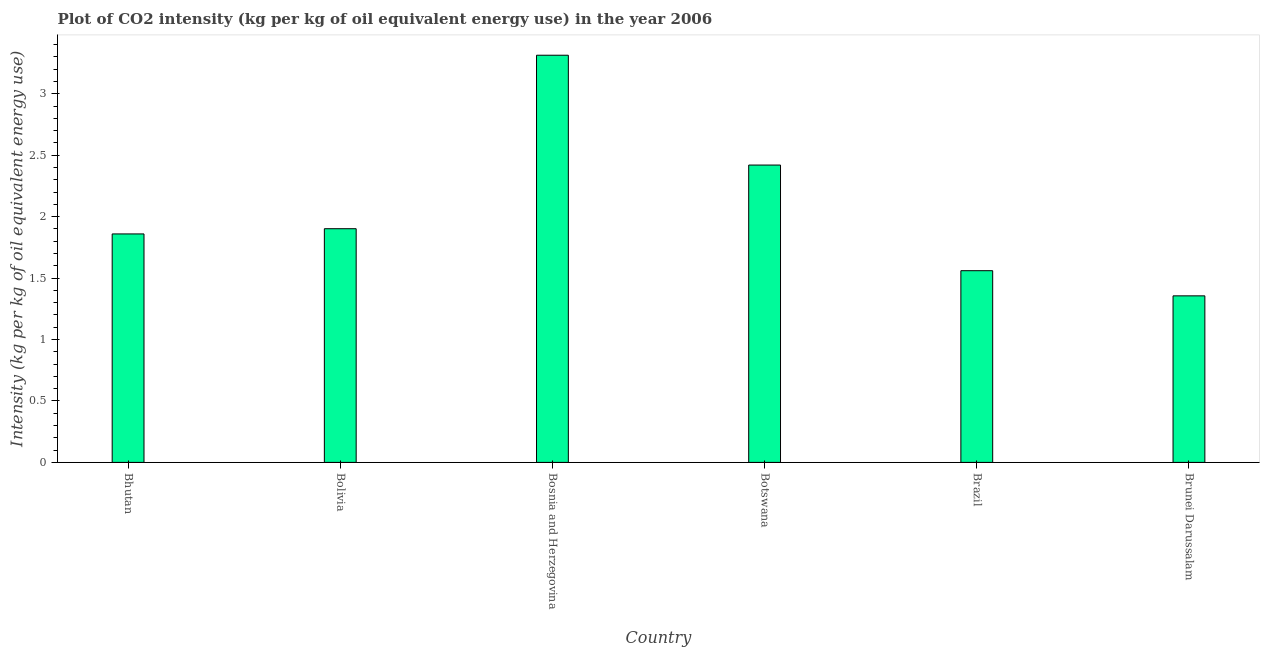Does the graph contain any zero values?
Your answer should be compact. No. What is the title of the graph?
Offer a very short reply. Plot of CO2 intensity (kg per kg of oil equivalent energy use) in the year 2006. What is the label or title of the X-axis?
Make the answer very short. Country. What is the label or title of the Y-axis?
Offer a very short reply. Intensity (kg per kg of oil equivalent energy use). What is the co2 intensity in Brazil?
Your answer should be compact. 1.56. Across all countries, what is the maximum co2 intensity?
Your answer should be very brief. 3.31. Across all countries, what is the minimum co2 intensity?
Your answer should be very brief. 1.36. In which country was the co2 intensity maximum?
Ensure brevity in your answer.  Bosnia and Herzegovina. In which country was the co2 intensity minimum?
Keep it short and to the point. Brunei Darussalam. What is the sum of the co2 intensity?
Provide a short and direct response. 12.41. What is the difference between the co2 intensity in Bolivia and Botswana?
Keep it short and to the point. -0.52. What is the average co2 intensity per country?
Provide a succinct answer. 2.07. What is the median co2 intensity?
Provide a short and direct response. 1.88. In how many countries, is the co2 intensity greater than 1.2 kg?
Offer a very short reply. 6. What is the ratio of the co2 intensity in Botswana to that in Brunei Darussalam?
Your answer should be very brief. 1.78. Is the co2 intensity in Bhutan less than that in Brazil?
Your response must be concise. No. Is the difference between the co2 intensity in Bolivia and Brunei Darussalam greater than the difference between any two countries?
Your response must be concise. No. What is the difference between the highest and the second highest co2 intensity?
Provide a short and direct response. 0.89. What is the difference between the highest and the lowest co2 intensity?
Offer a terse response. 1.96. Are the values on the major ticks of Y-axis written in scientific E-notation?
Keep it short and to the point. No. What is the Intensity (kg per kg of oil equivalent energy use) in Bhutan?
Your answer should be very brief. 1.86. What is the Intensity (kg per kg of oil equivalent energy use) in Bolivia?
Provide a short and direct response. 1.9. What is the Intensity (kg per kg of oil equivalent energy use) of Bosnia and Herzegovina?
Your answer should be very brief. 3.31. What is the Intensity (kg per kg of oil equivalent energy use) of Botswana?
Ensure brevity in your answer.  2.42. What is the Intensity (kg per kg of oil equivalent energy use) of Brazil?
Keep it short and to the point. 1.56. What is the Intensity (kg per kg of oil equivalent energy use) in Brunei Darussalam?
Give a very brief answer. 1.36. What is the difference between the Intensity (kg per kg of oil equivalent energy use) in Bhutan and Bolivia?
Your answer should be very brief. -0.04. What is the difference between the Intensity (kg per kg of oil equivalent energy use) in Bhutan and Bosnia and Herzegovina?
Provide a short and direct response. -1.45. What is the difference between the Intensity (kg per kg of oil equivalent energy use) in Bhutan and Botswana?
Give a very brief answer. -0.56. What is the difference between the Intensity (kg per kg of oil equivalent energy use) in Bhutan and Brazil?
Provide a succinct answer. 0.3. What is the difference between the Intensity (kg per kg of oil equivalent energy use) in Bhutan and Brunei Darussalam?
Provide a succinct answer. 0.5. What is the difference between the Intensity (kg per kg of oil equivalent energy use) in Bolivia and Bosnia and Herzegovina?
Your answer should be very brief. -1.41. What is the difference between the Intensity (kg per kg of oil equivalent energy use) in Bolivia and Botswana?
Offer a terse response. -0.52. What is the difference between the Intensity (kg per kg of oil equivalent energy use) in Bolivia and Brazil?
Your response must be concise. 0.34. What is the difference between the Intensity (kg per kg of oil equivalent energy use) in Bolivia and Brunei Darussalam?
Keep it short and to the point. 0.55. What is the difference between the Intensity (kg per kg of oil equivalent energy use) in Bosnia and Herzegovina and Botswana?
Make the answer very short. 0.89. What is the difference between the Intensity (kg per kg of oil equivalent energy use) in Bosnia and Herzegovina and Brazil?
Give a very brief answer. 1.75. What is the difference between the Intensity (kg per kg of oil equivalent energy use) in Bosnia and Herzegovina and Brunei Darussalam?
Provide a succinct answer. 1.96. What is the difference between the Intensity (kg per kg of oil equivalent energy use) in Botswana and Brazil?
Provide a short and direct response. 0.86. What is the difference between the Intensity (kg per kg of oil equivalent energy use) in Botswana and Brunei Darussalam?
Offer a very short reply. 1.06. What is the difference between the Intensity (kg per kg of oil equivalent energy use) in Brazil and Brunei Darussalam?
Give a very brief answer. 0.2. What is the ratio of the Intensity (kg per kg of oil equivalent energy use) in Bhutan to that in Bolivia?
Offer a very short reply. 0.98. What is the ratio of the Intensity (kg per kg of oil equivalent energy use) in Bhutan to that in Bosnia and Herzegovina?
Ensure brevity in your answer.  0.56. What is the ratio of the Intensity (kg per kg of oil equivalent energy use) in Bhutan to that in Botswana?
Your answer should be compact. 0.77. What is the ratio of the Intensity (kg per kg of oil equivalent energy use) in Bhutan to that in Brazil?
Provide a short and direct response. 1.19. What is the ratio of the Intensity (kg per kg of oil equivalent energy use) in Bhutan to that in Brunei Darussalam?
Ensure brevity in your answer.  1.37. What is the ratio of the Intensity (kg per kg of oil equivalent energy use) in Bolivia to that in Bosnia and Herzegovina?
Your response must be concise. 0.57. What is the ratio of the Intensity (kg per kg of oil equivalent energy use) in Bolivia to that in Botswana?
Your response must be concise. 0.79. What is the ratio of the Intensity (kg per kg of oil equivalent energy use) in Bolivia to that in Brazil?
Your answer should be compact. 1.22. What is the ratio of the Intensity (kg per kg of oil equivalent energy use) in Bolivia to that in Brunei Darussalam?
Make the answer very short. 1.4. What is the ratio of the Intensity (kg per kg of oil equivalent energy use) in Bosnia and Herzegovina to that in Botswana?
Keep it short and to the point. 1.37. What is the ratio of the Intensity (kg per kg of oil equivalent energy use) in Bosnia and Herzegovina to that in Brazil?
Your answer should be very brief. 2.12. What is the ratio of the Intensity (kg per kg of oil equivalent energy use) in Bosnia and Herzegovina to that in Brunei Darussalam?
Your response must be concise. 2.44. What is the ratio of the Intensity (kg per kg of oil equivalent energy use) in Botswana to that in Brazil?
Provide a short and direct response. 1.55. What is the ratio of the Intensity (kg per kg of oil equivalent energy use) in Botswana to that in Brunei Darussalam?
Make the answer very short. 1.78. What is the ratio of the Intensity (kg per kg of oil equivalent energy use) in Brazil to that in Brunei Darussalam?
Your response must be concise. 1.15. 